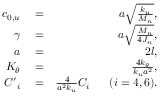Convert formula to latex. <formula><loc_0><loc_0><loc_500><loc_500>\begin{array} { r l r } { { { c } _ { 0 , u } } } & = } & { a \sqrt { \frac { { { k } _ { u } } } { { { M } _ { n } } } } , } \\ { \gamma } & = } & { a \sqrt { \frac { { { M } _ { n } } } { 4 { { J } _ { n } } } } , } \\ { a } & = } & { 2 l , } \\ { { { K } _ { \theta } } } & = } & { \frac { 4 { { k } _ { \theta } } } { { { k } _ { u } } { { a } ^ { 2 } } } , } \\ { { { { C } ^ { \prime } } _ { i } } } & = } & { \frac { 4 } { { { a } ^ { 2 } } { { k } _ { u } } } { { C } _ { i } } \quad \ ( i = 4 , 6 ) . } \end{array}</formula> 